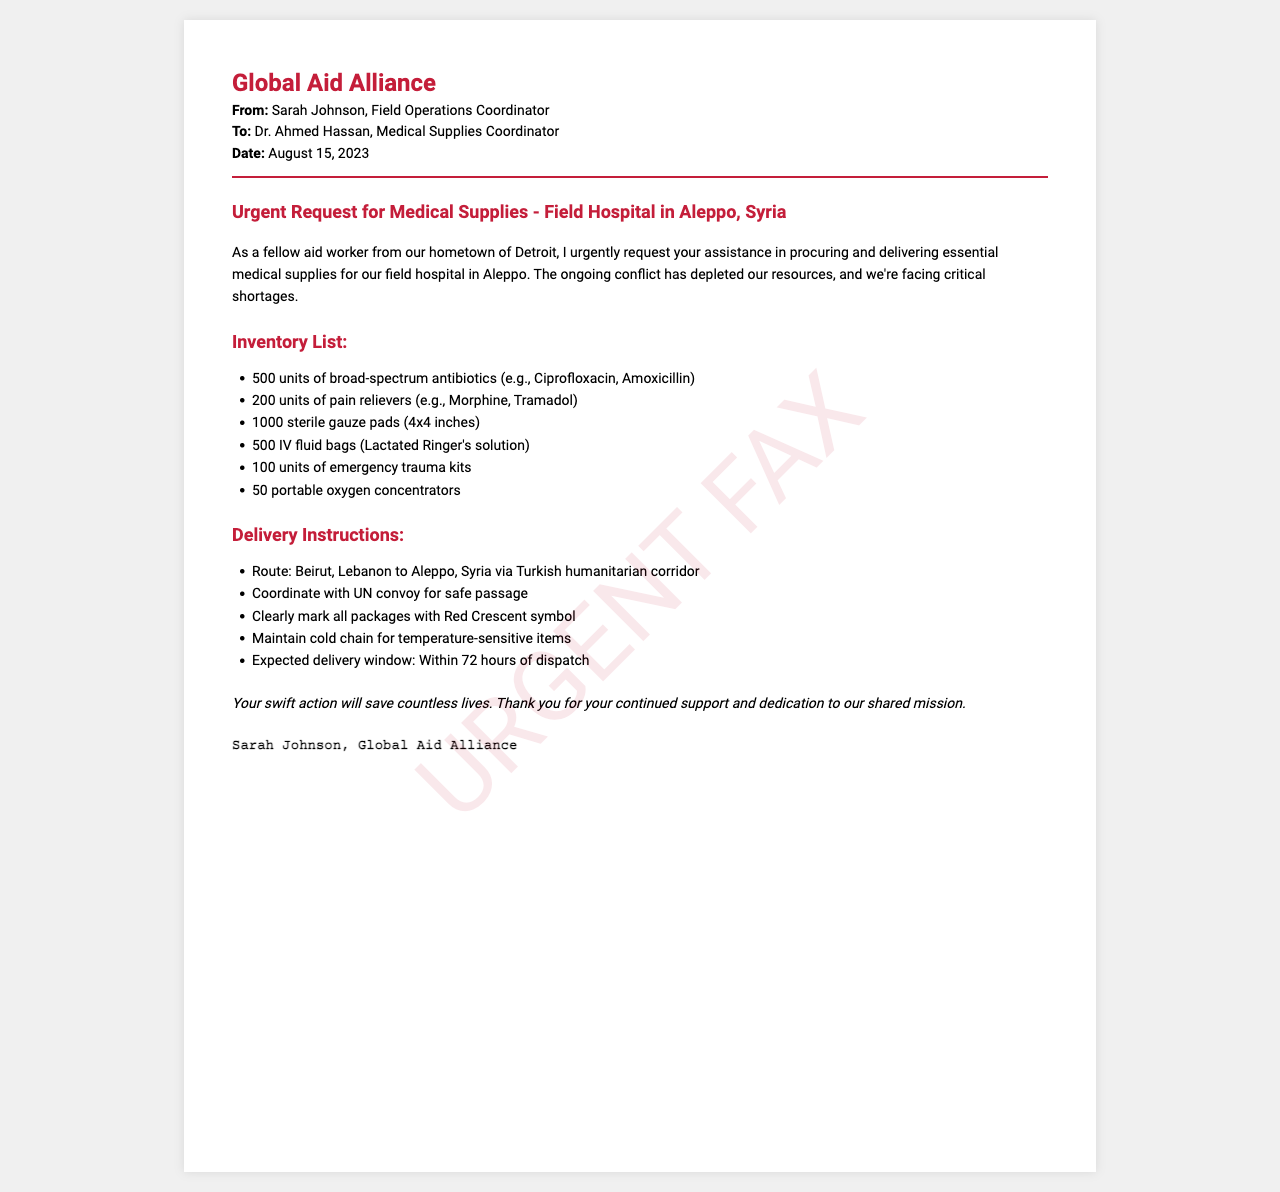What is the sender's name? The sender is Sarah Johnson, as stated in the header.
Answer: Sarah Johnson What date was the fax sent? The fax was sent on August 15, 2023, as mentioned in the header.
Answer: August 15, 2023 How many units of broad-spectrum antibiotics are requested? The document specifies 500 units of broad-spectrum antibiotics in the inventory list.
Answer: 500 units What is the primary destination for the medical supplies? The supplies are destined for the field hospital in Aleppo, Syria, as stated in the title.
Answer: Aleppo, Syria What are the instructions for package markings? The instructions specify that all packages should be clearly marked with the Red Crescent symbol.
Answer: Red Crescent symbol Why is the request considered urgent? The request is urgent due to critical shortages caused by ongoing conflict, as mentioned in the introduction.
Answer: Critical shortages How will the supplies be transported? The supplies will be transported via the Turkish humanitarian corridor, as stated in the delivery instructions.
Answer: Turkish humanitarian corridor Who should be coordinated with for safe passage? Coordination is required with the UN convoy for safe passage, as stated in the delivery instructions.
Answer: UN convoy What is the expected delivery window? The expected delivery window is within 72 hours of dispatch, as specified in the delivery instructions.
Answer: 72 hours 